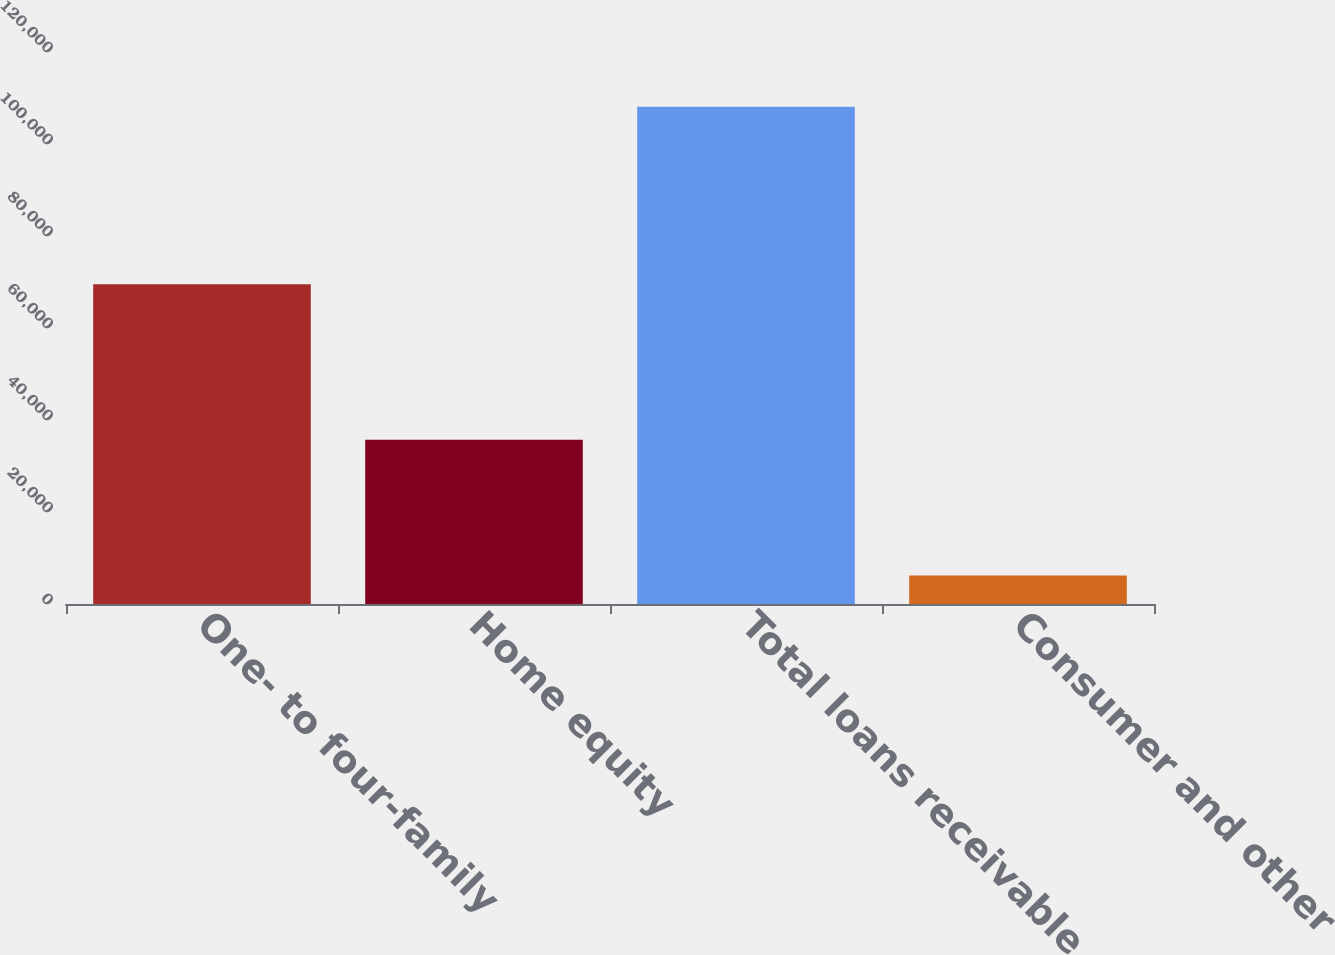<chart> <loc_0><loc_0><loc_500><loc_500><bar_chart><fcel>One- to four-family<fcel>Home equity<fcel>Total loans receivable<fcel>Consumer and other<nl><fcel>69522<fcel>35721<fcel>108084<fcel>6178<nl></chart> 